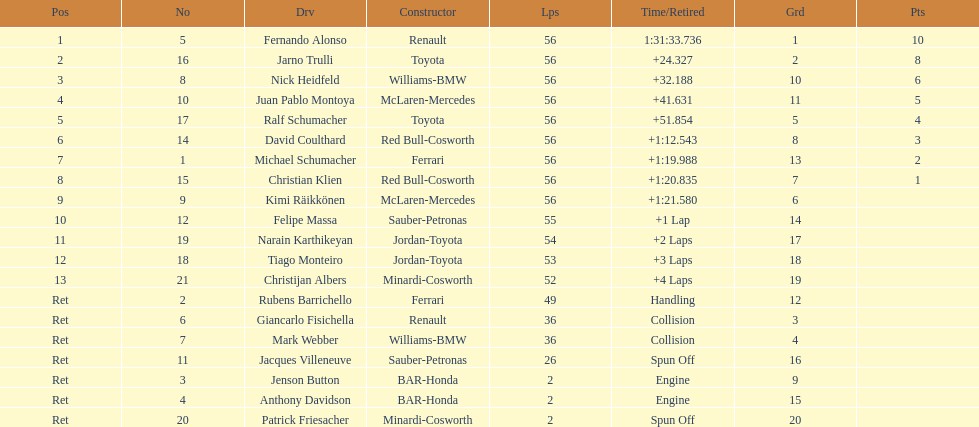How long did it take for heidfeld to finish? 1:31:65.924. 